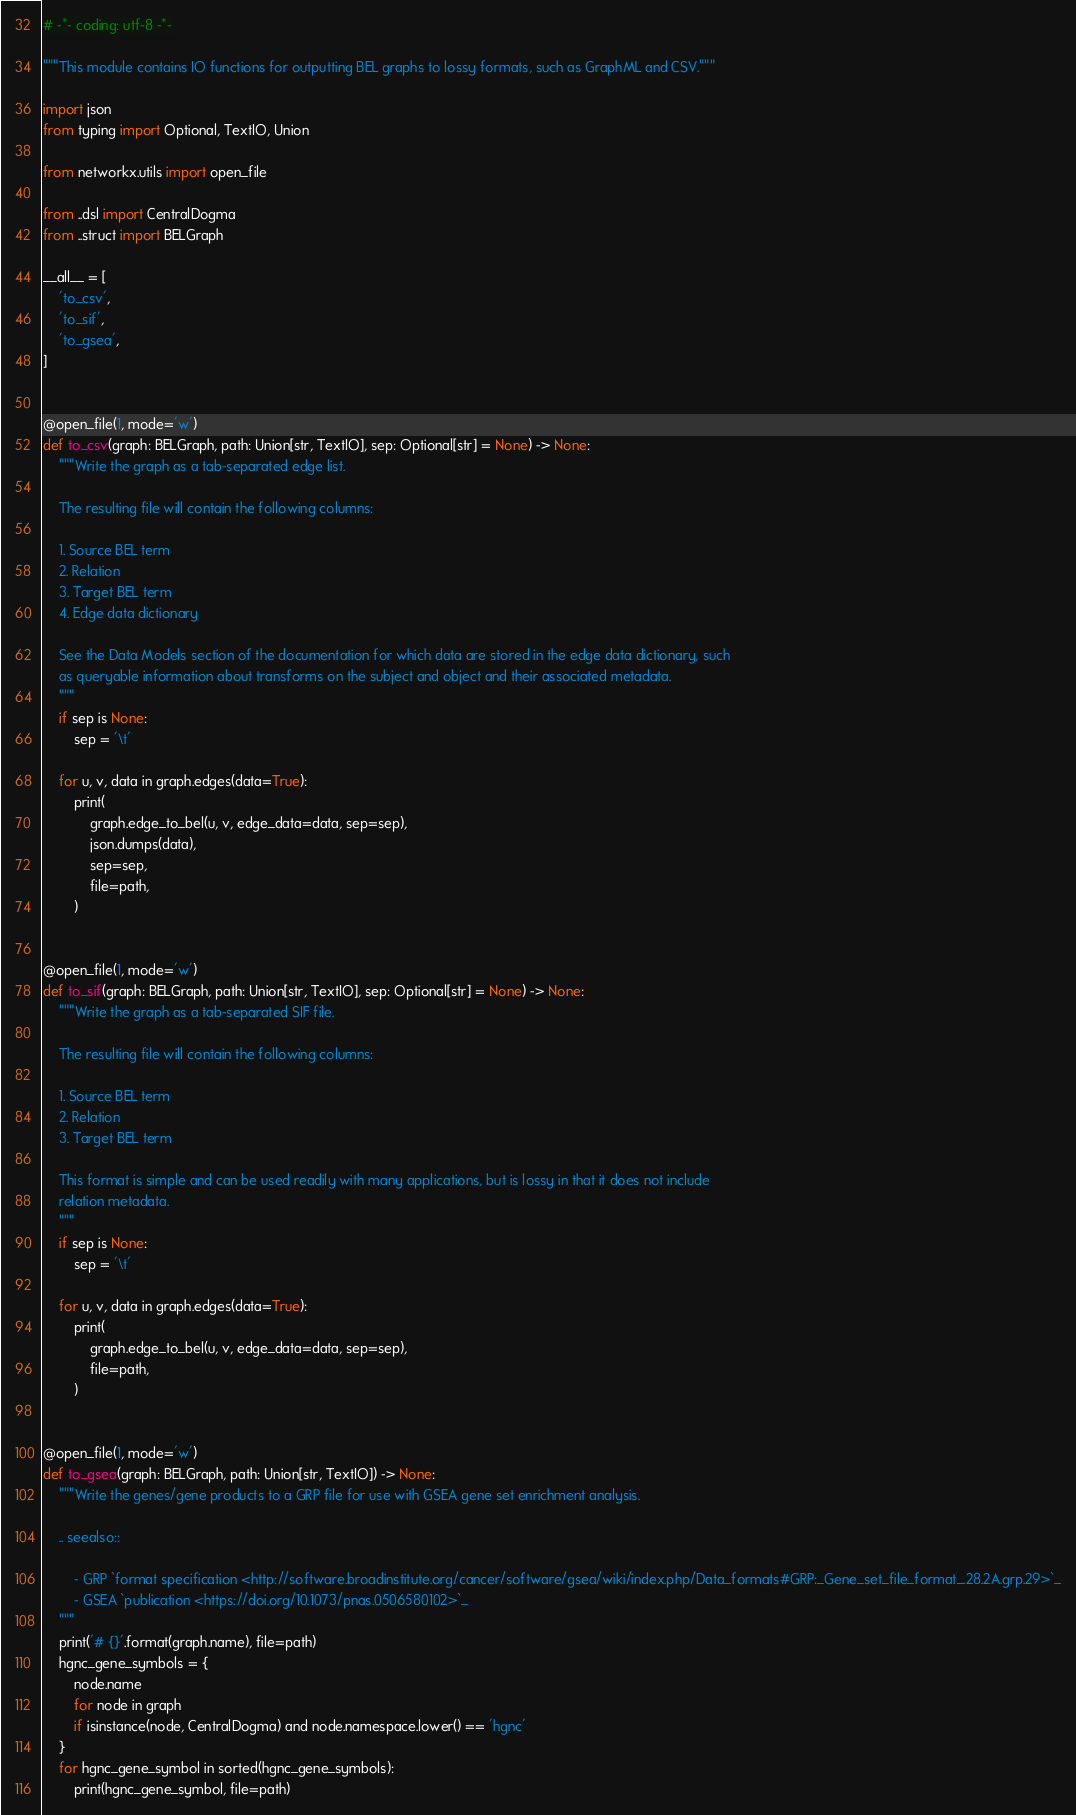<code> <loc_0><loc_0><loc_500><loc_500><_Python_># -*- coding: utf-8 -*-

"""This module contains IO functions for outputting BEL graphs to lossy formats, such as GraphML and CSV."""

import json
from typing import Optional, TextIO, Union

from networkx.utils import open_file

from ..dsl import CentralDogma
from ..struct import BELGraph

__all__ = [
    'to_csv',
    'to_sif',
    'to_gsea',
]


@open_file(1, mode='w')
def to_csv(graph: BELGraph, path: Union[str, TextIO], sep: Optional[str] = None) -> None:
    """Write the graph as a tab-separated edge list.

    The resulting file will contain the following columns:

    1. Source BEL term
    2. Relation
    3. Target BEL term
    4. Edge data dictionary

    See the Data Models section of the documentation for which data are stored in the edge data dictionary, such
    as queryable information about transforms on the subject and object and their associated metadata.
    """
    if sep is None:
        sep = '\t'

    for u, v, data in graph.edges(data=True):
        print(
            graph.edge_to_bel(u, v, edge_data=data, sep=sep),
            json.dumps(data),
            sep=sep,
            file=path,
        )


@open_file(1, mode='w')
def to_sif(graph: BELGraph, path: Union[str, TextIO], sep: Optional[str] = None) -> None:
    """Write the graph as a tab-separated SIF file.

    The resulting file will contain the following columns:

    1. Source BEL term
    2. Relation
    3. Target BEL term

    This format is simple and can be used readily with many applications, but is lossy in that it does not include
    relation metadata.
    """
    if sep is None:
        sep = '\t'

    for u, v, data in graph.edges(data=True):
        print(
            graph.edge_to_bel(u, v, edge_data=data, sep=sep),
            file=path,
        )


@open_file(1, mode='w')
def to_gsea(graph: BELGraph, path: Union[str, TextIO]) -> None:
    """Write the genes/gene products to a GRP file for use with GSEA gene set enrichment analysis.

    .. seealso::

        - GRP `format specification <http://software.broadinstitute.org/cancer/software/gsea/wiki/index.php/Data_formats#GRP:_Gene_set_file_format_.28.2A.grp.29>`_
        - GSEA `publication <https://doi.org/10.1073/pnas.0506580102>`_
    """
    print('# {}'.format(graph.name), file=path)
    hgnc_gene_symbols = {
        node.name
        for node in graph
        if isinstance(node, CentralDogma) and node.namespace.lower() == 'hgnc'
    }
    for hgnc_gene_symbol in sorted(hgnc_gene_symbols):
        print(hgnc_gene_symbol, file=path)
</code> 